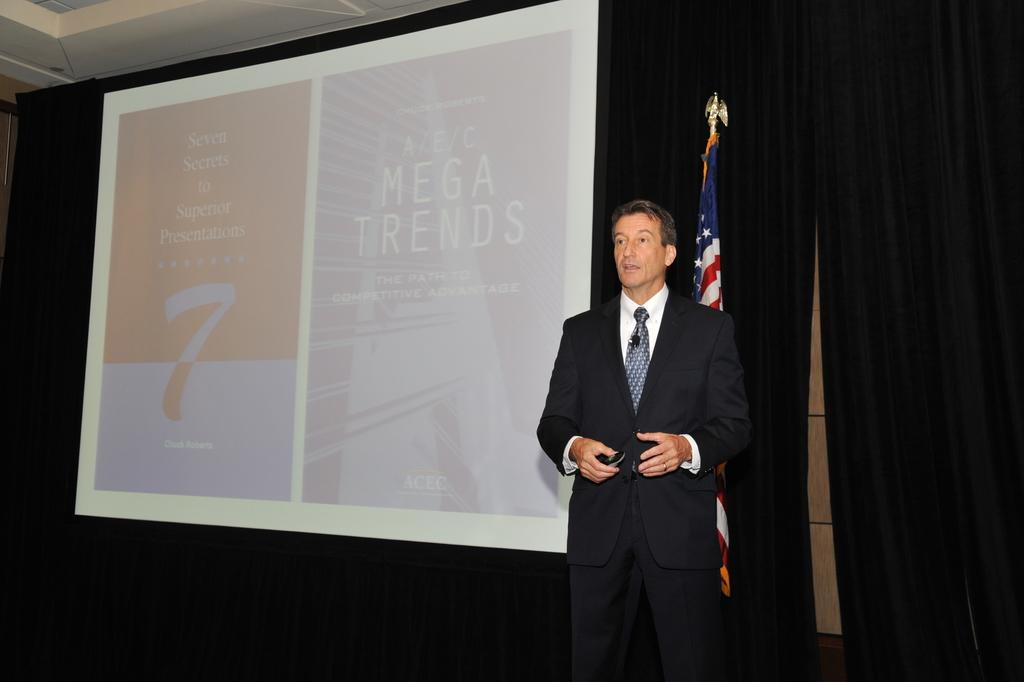What is the man in the image wearing? The man is wearing a blazer and a tie. What is the man holding in his hand? The man is holding a device in his hand. What is the man's posture in the image? The man is standing. What can be seen in the background of the image? There is a flag, a screen, and curtains in the background of the image. What type of pear is being used to clean the soap in the image? There is no pear or soap present in the image. 